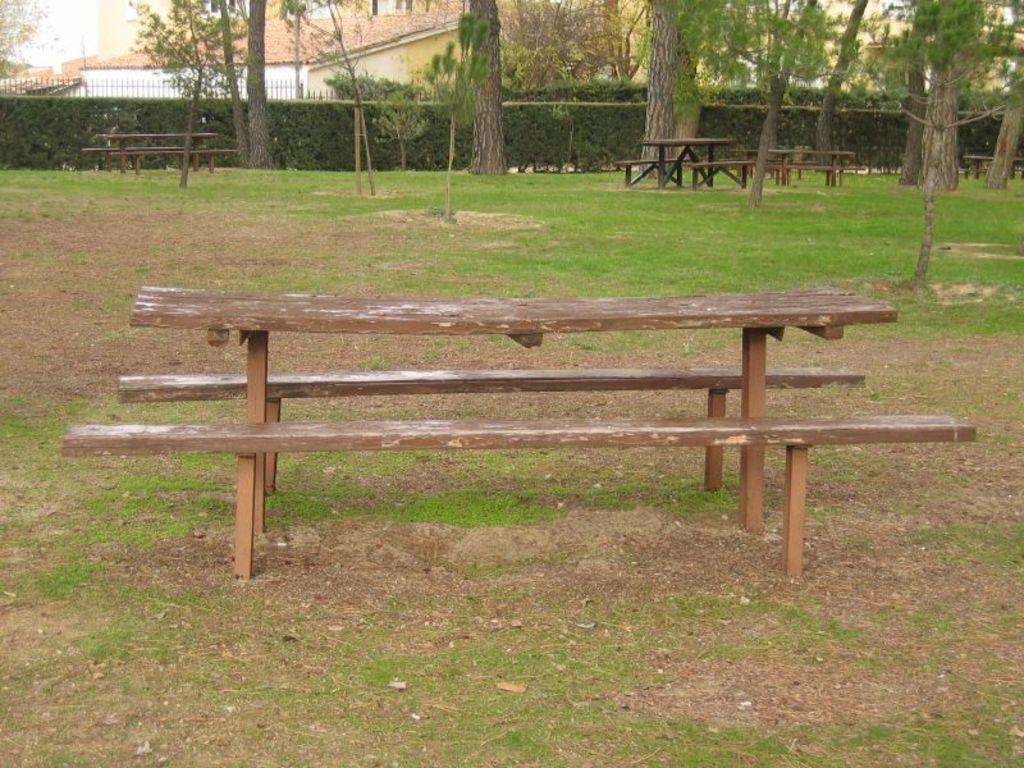What type of seating is visible in the image? There is a wooden bench in the image. What can be seen in the background of the image? There are trees and a building in the background of the image. What is the color of the trees in the image? The trees are green. What is the color of the building in the image? The building is white. What else is visible in the background of the image? The sky is visible in the background of the image. What is the color of the sky in the image? The sky is white. Is there a girl celebrating her birthday on the wooden bench in the image? There is no girl or birthday celebration present in the image. What type of pump is visible near the trees in the image? There is no pump present in the image. 